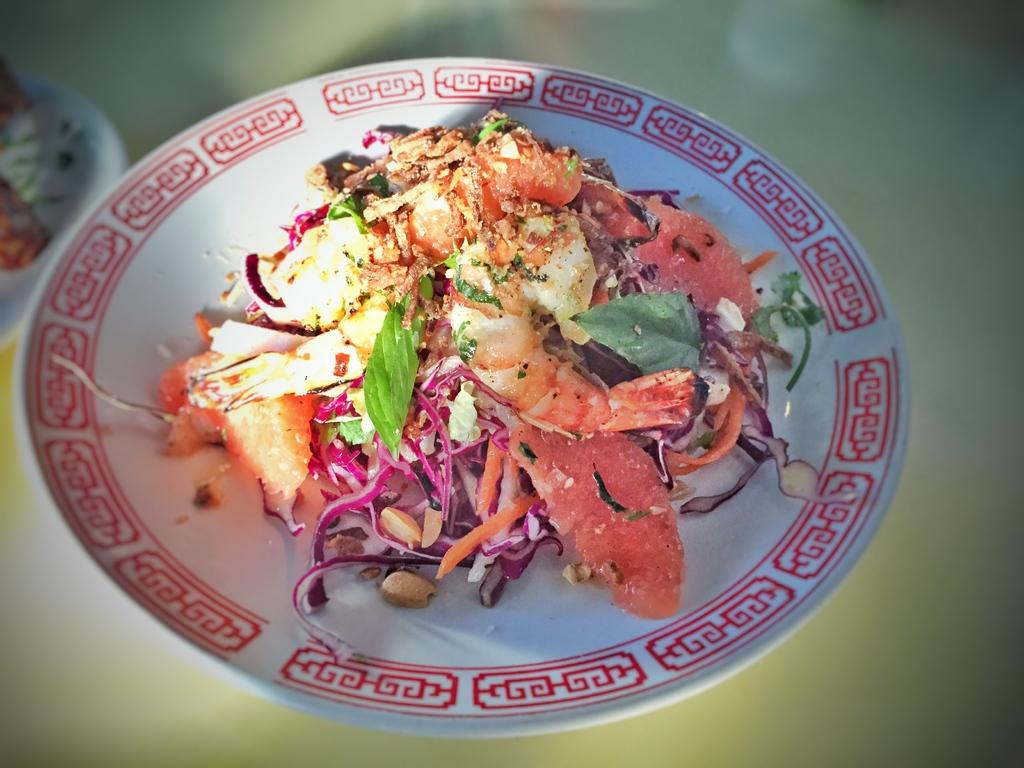What is on the plate that is visible in the image? There is food on a plate in the image. Where is the plate located in the image? The plate is present on a table in the image. What language is spoken by the cherries on the plate? There are no cherries present in the image, and fruits do not speak languages. 